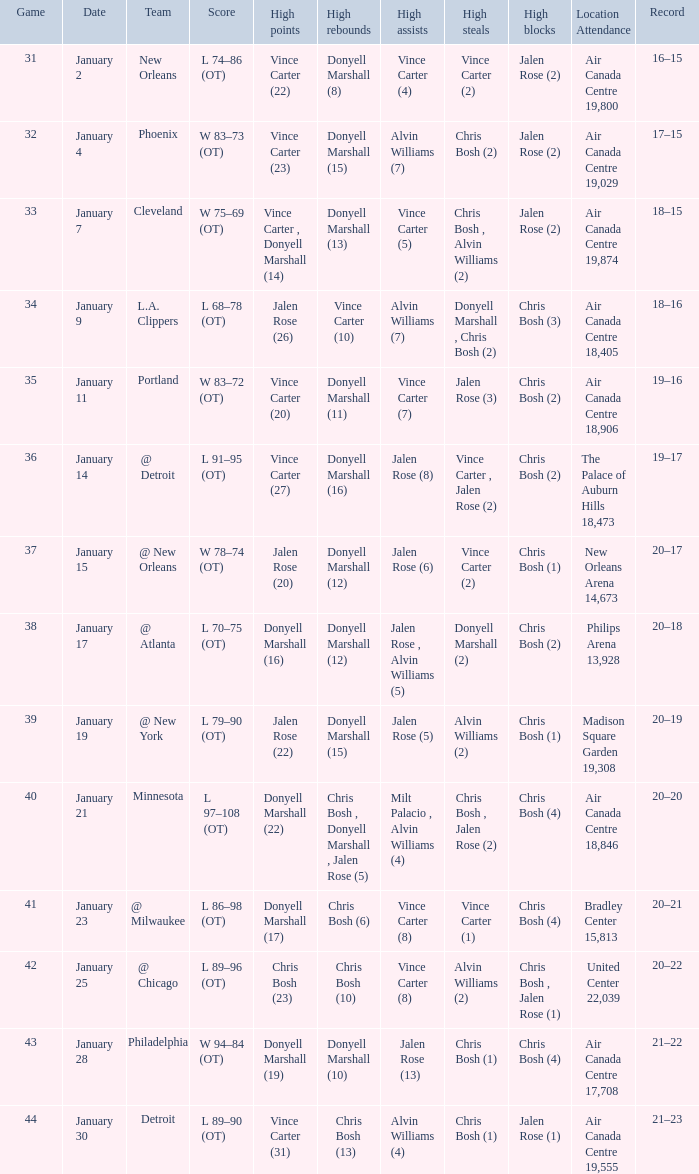Could you parse the entire table? {'header': ['Game', 'Date', 'Team', 'Score', 'High points', 'High rebounds', 'High assists', 'High steals', 'High blocks', 'Location Attendance', 'Record'], 'rows': [['31', 'January 2', 'New Orleans', 'L 74–86 (OT)', 'Vince Carter (22)', 'Donyell Marshall (8)', 'Vince Carter (4)', 'Vince Carter (2)', 'Jalen Rose (2)', 'Air Canada Centre 19,800', '16–15'], ['32', 'January 4', 'Phoenix', 'W 83–73 (OT)', 'Vince Carter (23)', 'Donyell Marshall (15)', 'Alvin Williams (7)', 'Chris Bosh (2)', 'Jalen Rose (2)', 'Air Canada Centre 19,029', '17–15'], ['33', 'January 7', 'Cleveland', 'W 75–69 (OT)', 'Vince Carter , Donyell Marshall (14)', 'Donyell Marshall (13)', 'Vince Carter (5)', 'Chris Bosh , Alvin Williams (2)', 'Jalen Rose (2)', 'Air Canada Centre 19,874', '18–15'], ['34', 'January 9', 'L.A. Clippers', 'L 68–78 (OT)', 'Jalen Rose (26)', 'Vince Carter (10)', 'Alvin Williams (7)', 'Donyell Marshall , Chris Bosh (2)', 'Chris Bosh (3)', 'Air Canada Centre 18,405', '18–16'], ['35', 'January 11', 'Portland', 'W 83–72 (OT)', 'Vince Carter (20)', 'Donyell Marshall (11)', 'Vince Carter (7)', 'Jalen Rose (3)', 'Chris Bosh (2)', 'Air Canada Centre 18,906', '19–16'], ['36', 'January 14', '@ Detroit', 'L 91–95 (OT)', 'Vince Carter (27)', 'Donyell Marshall (16)', 'Jalen Rose (8)', 'Vince Carter , Jalen Rose (2)', 'Chris Bosh (2)', 'The Palace of Auburn Hills 18,473', '19–17'], ['37', 'January 15', '@ New Orleans', 'W 78–74 (OT)', 'Jalen Rose (20)', 'Donyell Marshall (12)', 'Jalen Rose (6)', 'Vince Carter (2)', 'Chris Bosh (1)', 'New Orleans Arena 14,673', '20–17'], ['38', 'January 17', '@ Atlanta', 'L 70–75 (OT)', 'Donyell Marshall (16)', 'Donyell Marshall (12)', 'Jalen Rose , Alvin Williams (5)', 'Donyell Marshall (2)', 'Chris Bosh (2)', 'Philips Arena 13,928', '20–18'], ['39', 'January 19', '@ New York', 'L 79–90 (OT)', 'Jalen Rose (22)', 'Donyell Marshall (15)', 'Jalen Rose (5)', 'Alvin Williams (2)', 'Chris Bosh (1)', 'Madison Square Garden 19,308', '20–19'], ['40', 'January 21', 'Minnesota', 'L 97–108 (OT)', 'Donyell Marshall (22)', 'Chris Bosh , Donyell Marshall , Jalen Rose (5)', 'Milt Palacio , Alvin Williams (4)', 'Chris Bosh , Jalen Rose (2)', 'Chris Bosh (4)', 'Air Canada Centre 18,846', '20–20'], ['41', 'January 23', '@ Milwaukee', 'L 86–98 (OT)', 'Donyell Marshall (17)', 'Chris Bosh (6)', 'Vince Carter (8)', 'Vince Carter (1)', 'Chris Bosh (4)', 'Bradley Center 15,813', '20–21'], ['42', 'January 25', '@ Chicago', 'L 89–96 (OT)', 'Chris Bosh (23)', 'Chris Bosh (10)', 'Vince Carter (8)', 'Alvin Williams (2)', 'Chris Bosh , Jalen Rose (1)', 'United Center 22,039', '20–22'], ['43', 'January 28', 'Philadelphia', 'W 94–84 (OT)', 'Donyell Marshall (19)', 'Donyell Marshall (10)', 'Jalen Rose (13)', 'Chris Bosh (1)', 'Chris Bosh (4)', 'Air Canada Centre 17,708', '21–22'], ['44', 'January 30', 'Detroit', 'L 89–90 (OT)', 'Vince Carter (31)', 'Chris Bosh (13)', 'Alvin Williams (4)', 'Chris Bosh (1)', 'Jalen Rose (1)', 'Air Canada Centre 19,555', '21–23']]} Where was the game, and how many attended the game on january 2? Air Canada Centre 19,800. 